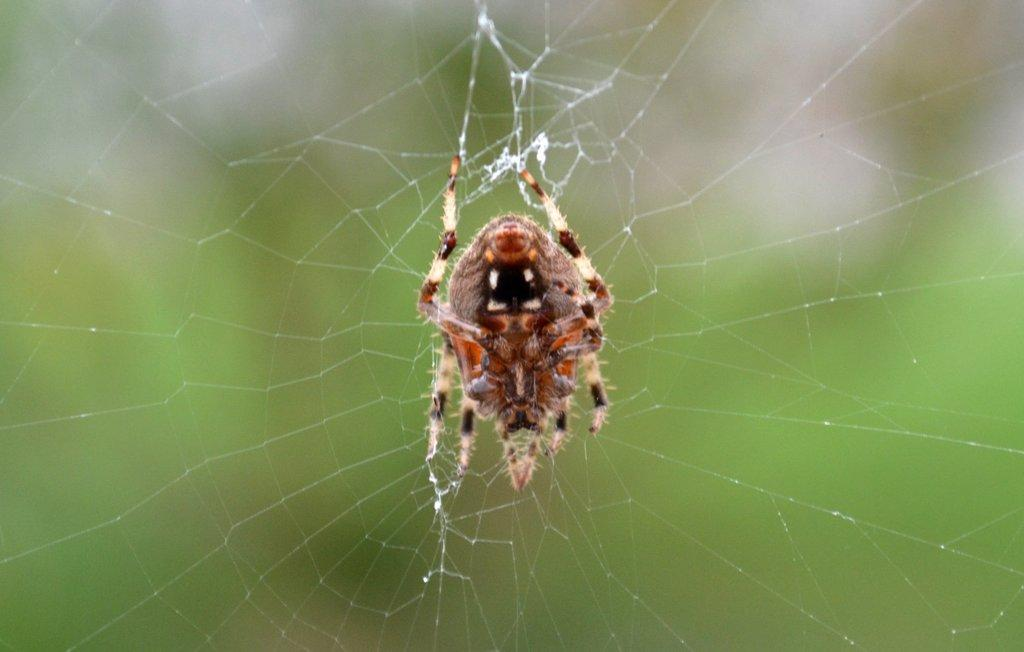What is the main subject of the image? The main subject of the image is a spider. Where is the spider located in the image? The spider is on a web in the image. What is the position of the spider and web in the image? The spider and web are in the center of the image. What note is the spider playing on the web in the image? There is no indication in the image that the spider is playing a musical note or any instrument. 